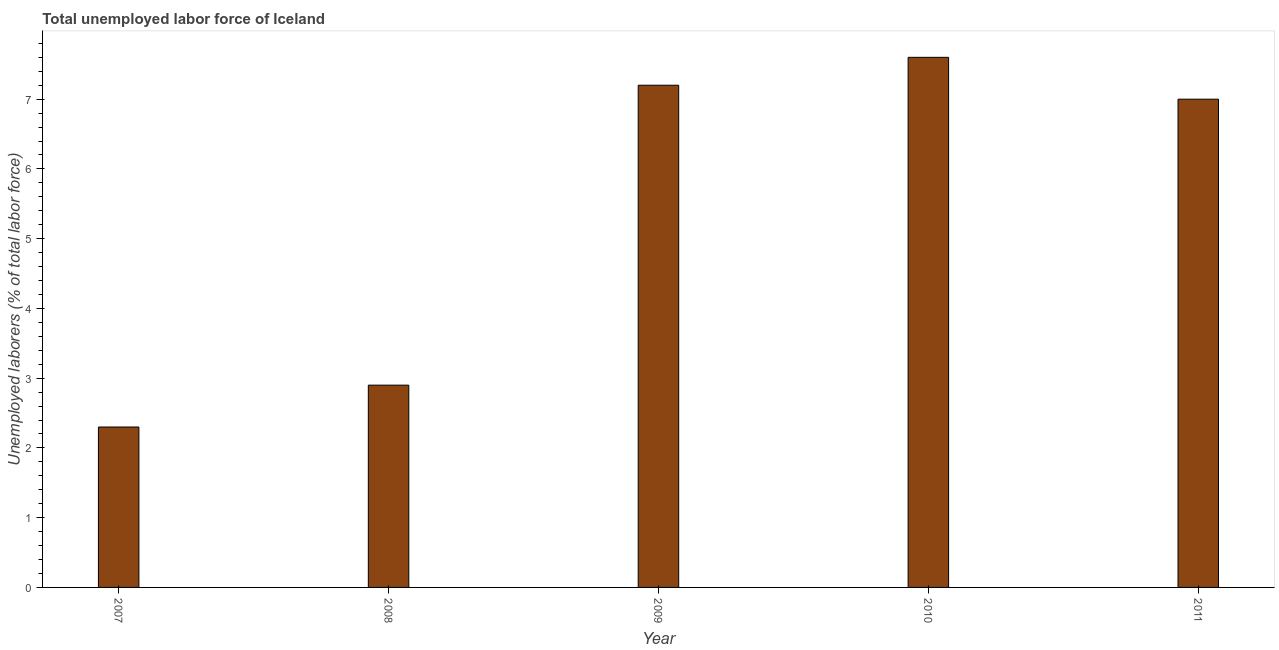Does the graph contain any zero values?
Give a very brief answer. No. What is the title of the graph?
Ensure brevity in your answer.  Total unemployed labor force of Iceland. What is the label or title of the Y-axis?
Your response must be concise. Unemployed laborers (% of total labor force). What is the total unemployed labour force in 2007?
Your answer should be compact. 2.3. Across all years, what is the maximum total unemployed labour force?
Offer a terse response. 7.6. Across all years, what is the minimum total unemployed labour force?
Offer a very short reply. 2.3. In which year was the total unemployed labour force maximum?
Give a very brief answer. 2010. What is the sum of the total unemployed labour force?
Offer a terse response. 27. In how many years, is the total unemployed labour force greater than 0.4 %?
Your answer should be compact. 5. What is the ratio of the total unemployed labour force in 2008 to that in 2011?
Ensure brevity in your answer.  0.41. What is the difference between the highest and the second highest total unemployed labour force?
Your answer should be very brief. 0.4. What is the difference between the highest and the lowest total unemployed labour force?
Offer a terse response. 5.3. In how many years, is the total unemployed labour force greater than the average total unemployed labour force taken over all years?
Make the answer very short. 3. How many bars are there?
Your answer should be very brief. 5. Are all the bars in the graph horizontal?
Provide a succinct answer. No. How many years are there in the graph?
Ensure brevity in your answer.  5. Are the values on the major ticks of Y-axis written in scientific E-notation?
Offer a terse response. No. What is the Unemployed laborers (% of total labor force) of 2007?
Give a very brief answer. 2.3. What is the Unemployed laborers (% of total labor force) of 2008?
Your answer should be compact. 2.9. What is the Unemployed laborers (% of total labor force) of 2009?
Offer a terse response. 7.2. What is the Unemployed laborers (% of total labor force) in 2010?
Provide a short and direct response. 7.6. What is the difference between the Unemployed laborers (% of total labor force) in 2007 and 2008?
Offer a very short reply. -0.6. What is the difference between the Unemployed laborers (% of total labor force) in 2007 and 2009?
Offer a terse response. -4.9. What is the difference between the Unemployed laborers (% of total labor force) in 2007 and 2010?
Make the answer very short. -5.3. What is the difference between the Unemployed laborers (% of total labor force) in 2007 and 2011?
Make the answer very short. -4.7. What is the difference between the Unemployed laborers (% of total labor force) in 2008 and 2009?
Offer a terse response. -4.3. What is the difference between the Unemployed laborers (% of total labor force) in 2008 and 2011?
Your answer should be compact. -4.1. What is the difference between the Unemployed laborers (% of total labor force) in 2009 and 2010?
Give a very brief answer. -0.4. What is the ratio of the Unemployed laborers (% of total labor force) in 2007 to that in 2008?
Keep it short and to the point. 0.79. What is the ratio of the Unemployed laborers (% of total labor force) in 2007 to that in 2009?
Offer a terse response. 0.32. What is the ratio of the Unemployed laborers (% of total labor force) in 2007 to that in 2010?
Offer a very short reply. 0.3. What is the ratio of the Unemployed laborers (% of total labor force) in 2007 to that in 2011?
Offer a very short reply. 0.33. What is the ratio of the Unemployed laborers (% of total labor force) in 2008 to that in 2009?
Your response must be concise. 0.4. What is the ratio of the Unemployed laborers (% of total labor force) in 2008 to that in 2010?
Offer a very short reply. 0.38. What is the ratio of the Unemployed laborers (% of total labor force) in 2008 to that in 2011?
Offer a terse response. 0.41. What is the ratio of the Unemployed laborers (% of total labor force) in 2009 to that in 2010?
Ensure brevity in your answer.  0.95. What is the ratio of the Unemployed laborers (% of total labor force) in 2010 to that in 2011?
Give a very brief answer. 1.09. 